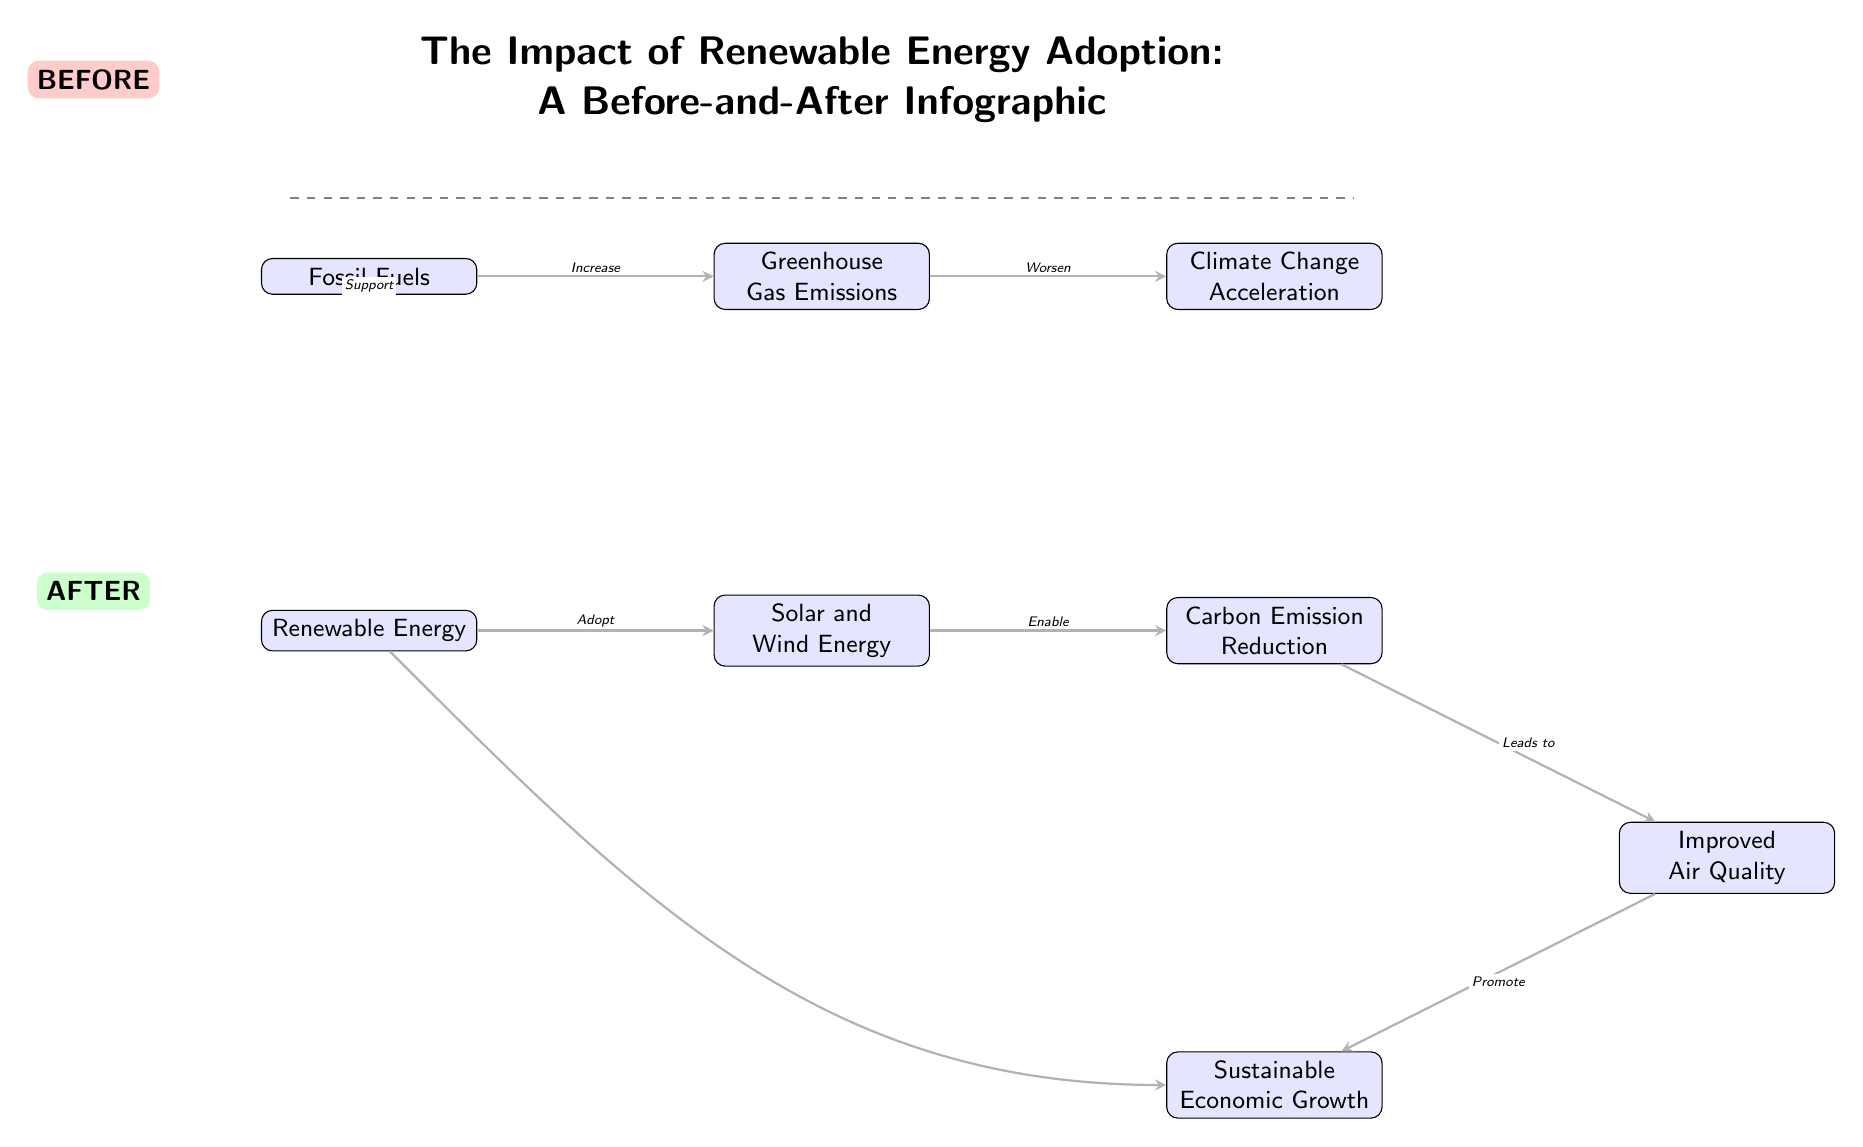What are the two types of energy mentioned in the diagram? The diagram includes two types of energy: Fossil Fuels and Renewable Energy. These are indicated as separate nodes on the left side of the infographic.
Answer: Fossil Fuels, Renewable Energy What does the arrow between Fossil Fuels and Greenhouse Gas Emissions indicate? The arrow signifies an increase in Greenhouse Gas Emissions as a result of using Fossil Fuels, as labeled on the connecting edge.
Answer: Increase How many nodes are represented in the "After" section of the diagram? The "After" section features four nodes: Renewable Energy, Solar and Wind Energy, Carbon Emission Reduction, and Improved Air Quality. Counting these, we see there are four distinct nodes.
Answer: 4 What outcome is promoted by Improved Air Quality? The diagram indicates that Improved Air Quality leads to Sustainable Economic Growth, as represented by the directed arrow linking these two nodes.
Answer: Sustainable Economic Growth What is the relationship between Renewable Energy and Sustainable Economic Growth in the diagram? The diagram shows that Renewable Energy supports Sustainable Economic Growth directly through a curved arrow connecting them, indicating a supportive relationship.
Answer: Support What happens to Climate Change as a result of increased Greenhouse Gas Emissions? The diagram illustrates that Climate Change worsens due to increased Greenhouse Gas Emissions, indicated by the directed arrow connecting those two nodes.
Answer: Worsen How is Carbon Emission Reduction achieved according to the diagram? Carbon Emission Reduction is achieved by adopting Solar and Wind Energy, as the arrow indicates that Solar and Wind Energy enable this reduction.
Answer: Enable What does the dashed line in the diagram represent? The dashed line serves as a visual separator between the "Before" and "After" sections of the infographic, indicating the transition from Fossil Fuels to Renewable Energy.
Answer: Divider What is the main theme of the diagram? The title of the diagram clearly states that the focus is on the impact of Renewable Energy adoption, framed within a before-and-after context.
Answer: The Impact of Renewable Energy Adoption 